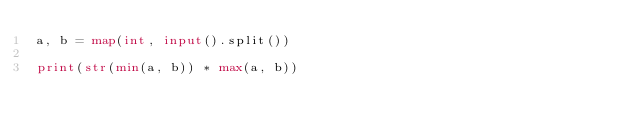Convert code to text. <code><loc_0><loc_0><loc_500><loc_500><_Python_>a, b = map(int, input().split())

print(str(min(a, b)) * max(a, b))</code> 